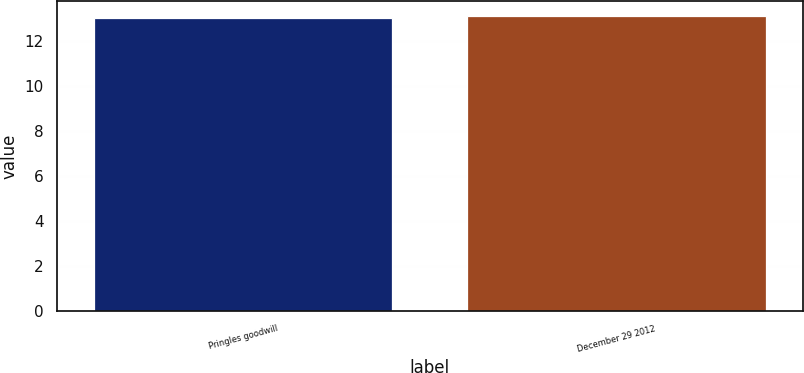Convert chart. <chart><loc_0><loc_0><loc_500><loc_500><bar_chart><fcel>Pringles goodwill<fcel>December 29 2012<nl><fcel>13<fcel>13.1<nl></chart> 